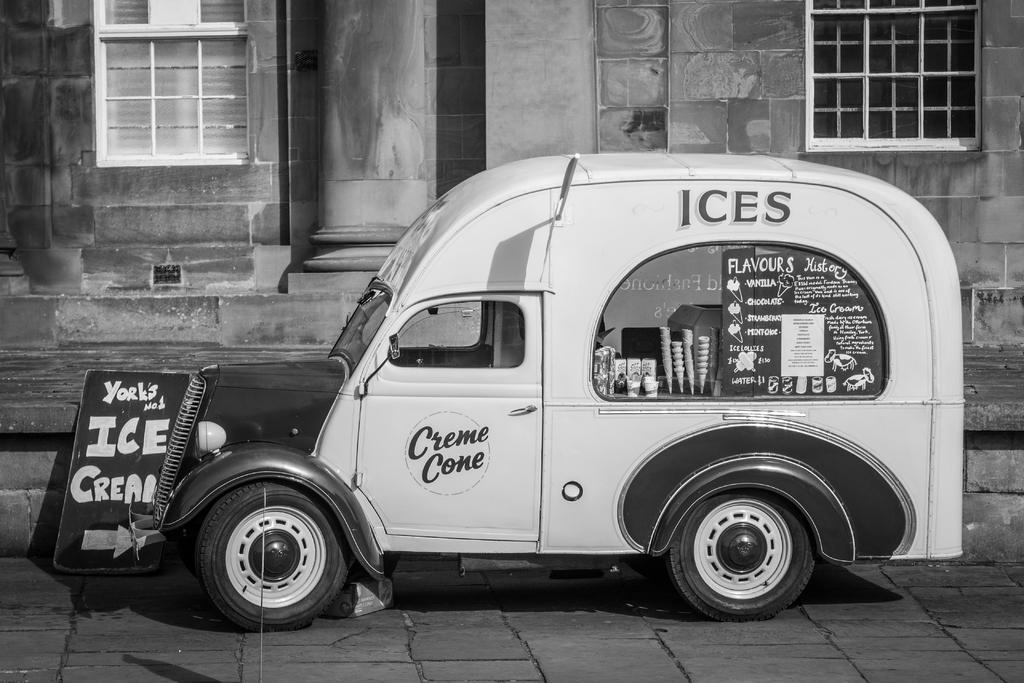How would you summarize this image in a sentence or two? In the foreground of this black and white image, there is a van. In the background, there is a board and the building. 